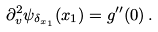Convert formula to latex. <formula><loc_0><loc_0><loc_500><loc_500>\partial ^ { 2 } _ { v } \psi _ { \delta _ { x _ { 1 } } } ( x _ { 1 } ) = g ^ { \prime \prime } ( 0 ) \, .</formula> 